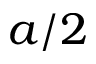<formula> <loc_0><loc_0><loc_500><loc_500>a / 2</formula> 